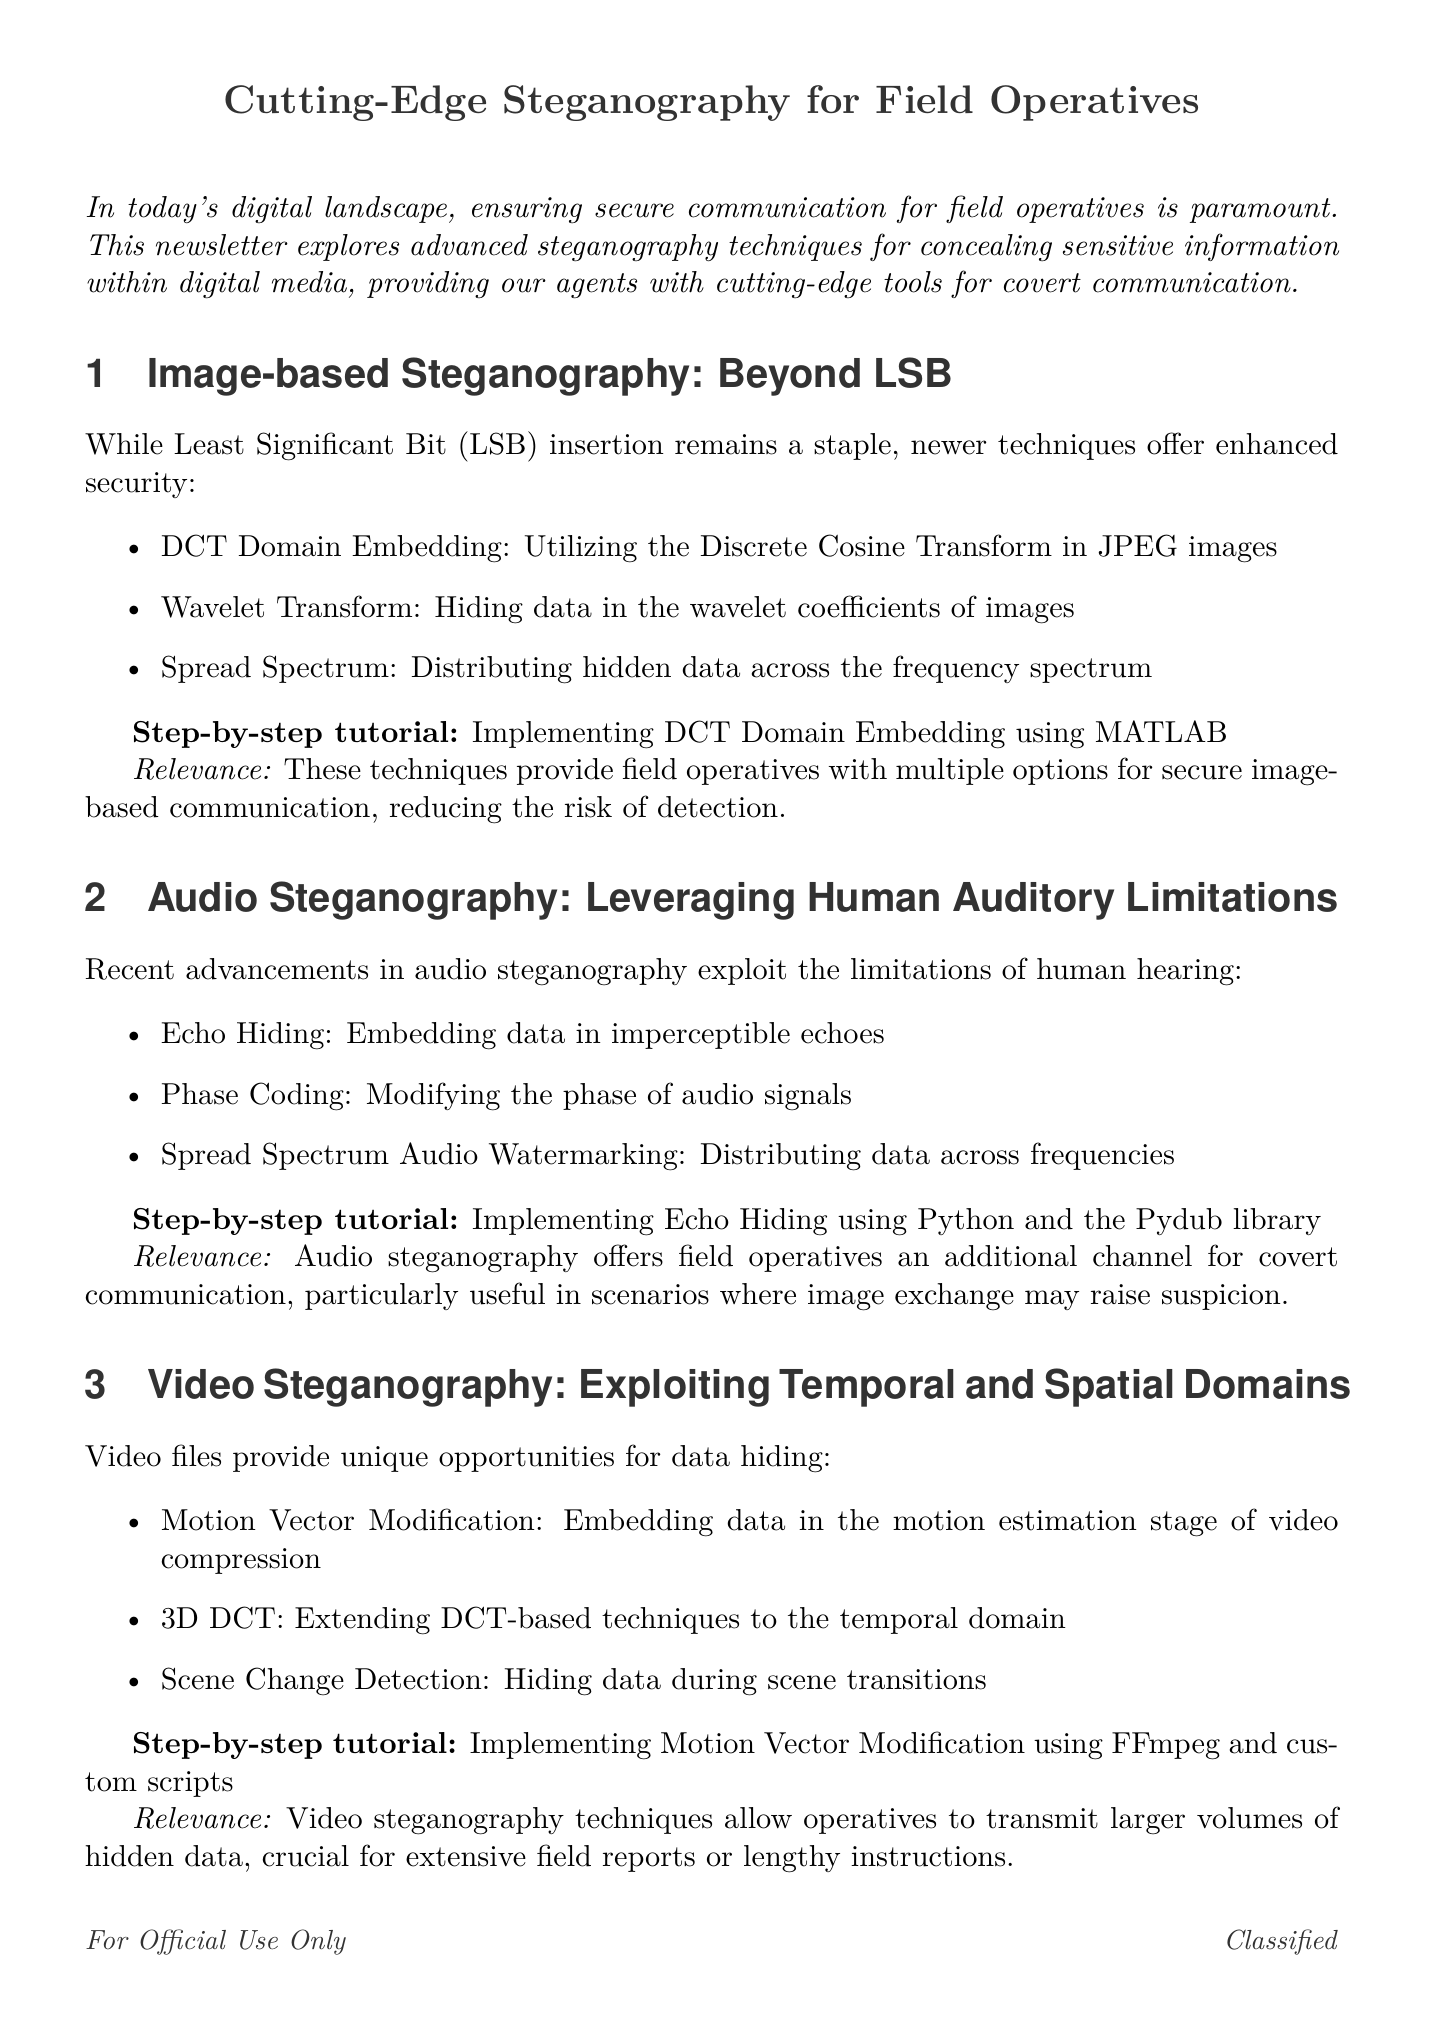What is the title of the newsletter? The title is clearly stated at the beginning of the document.
Answer: Secure Communications Digest: Cutting-Edge Steganography for Field Operatives How many sections are discussed in the newsletter? The document outlines distinct sections that detail various steganography techniques.
Answer: Five What technique is mentioned for image-based steganography? Techniques are listed under image-based steganography, providing specific methods used for data concealment.
Answer: DCT Domain Embedding What programming language is used in the audio steganography tutorial? The tutorial specifies the programming language used for implementing a particular technique.
Answer: Python What type of steganography is described as preparing for the future? The document discusses several advancements and future potentials in a specific area of steganography.
Answer: Quantum Steganography Which library is used in the Echo Hiding tutorial? The tutorial mentions a specific library used for implementation in audio steganography.
Answer: Pydub What is the relevance of video steganography for field operatives? The document explains why operatives find this technique particularly beneficial for their communication needs.
Answer: Transmit larger volumes of hidden data What tool is mentioned for implementing DNS Tunneling? The document lists a specific tool that can facilitate the implementation of a steganographic technique.
Answer: iodine What is a key characteristic of network steganography? The document provides a description highlighting the unique aspect of this type of steganography.
Answer: Hiding Data in Protocol Headers 